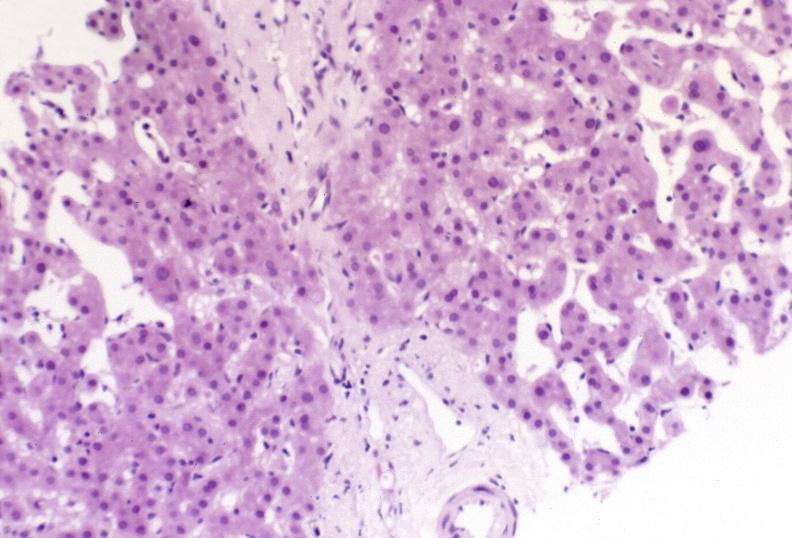does this image show ductopenia?
Answer the question using a single word or phrase. Yes 